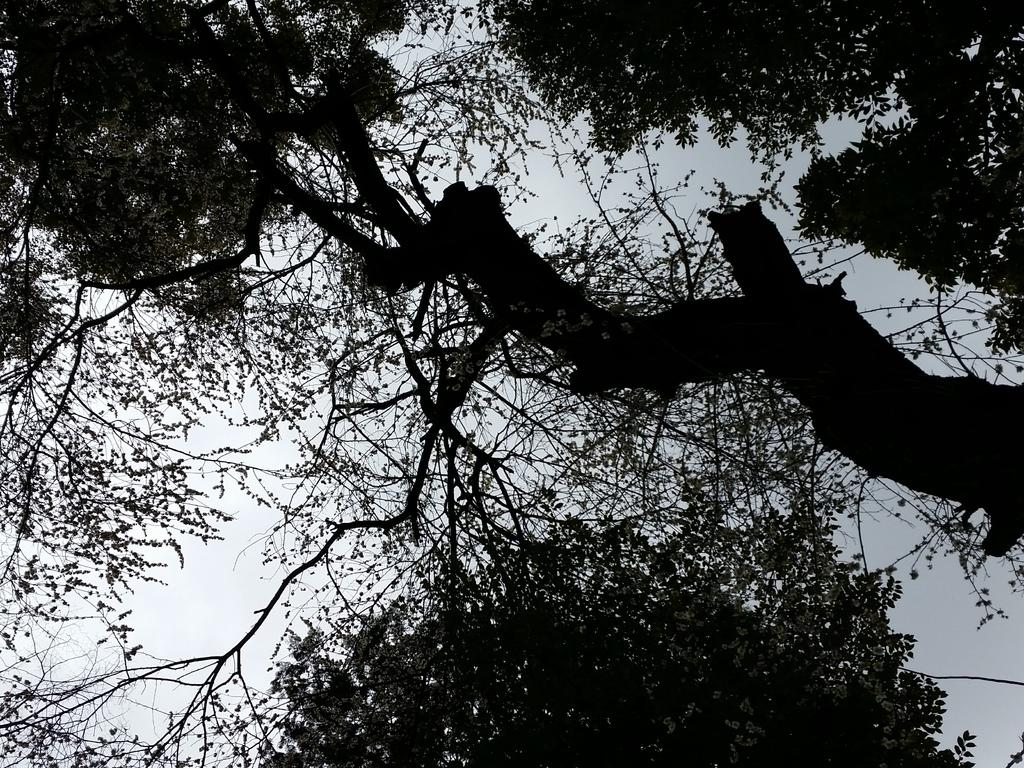What is the color scheme of the image? The image is black and white. What type of natural elements can be seen in the image? There are trees visible in the image. What else is visible in the image besides the trees? The sky is visible in the image. Can you tell me how much milk is being poured into the stream in the image? There is no milk or stream present in the image; it features a black and white scene with trees and the sky. Is there a servant visible in the image? There is no servant present in the image. 